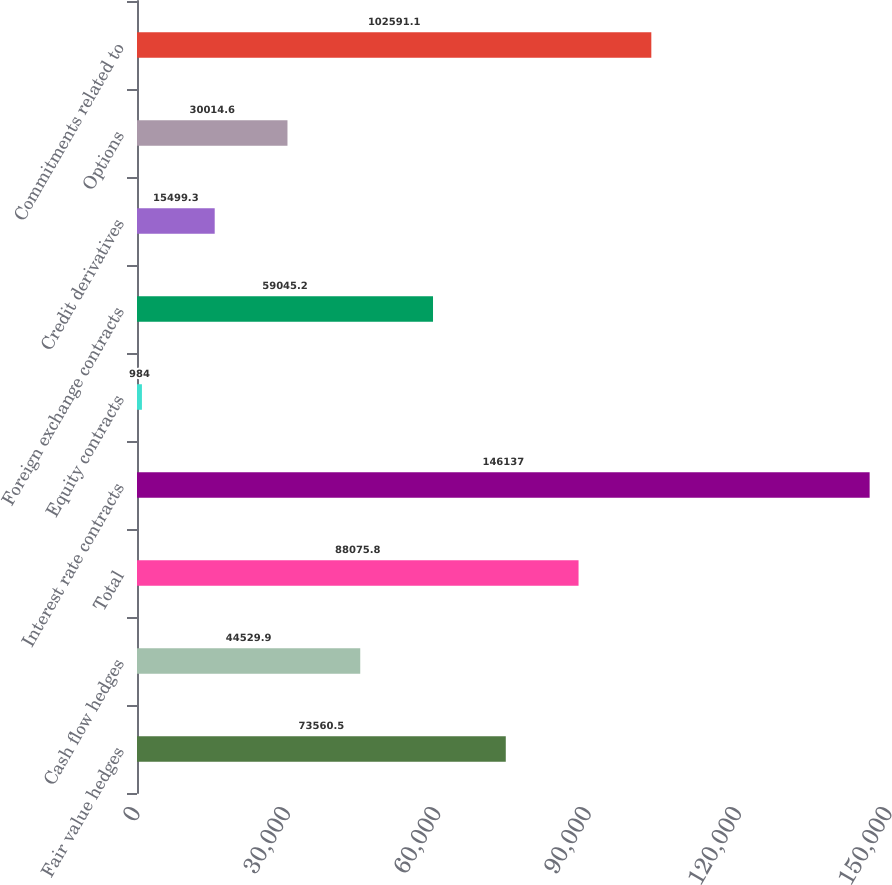<chart> <loc_0><loc_0><loc_500><loc_500><bar_chart><fcel>Fair value hedges<fcel>Cash flow hedges<fcel>Total<fcel>Interest rate contracts<fcel>Equity contracts<fcel>Foreign exchange contracts<fcel>Credit derivatives<fcel>Options<fcel>Commitments related to<nl><fcel>73560.5<fcel>44529.9<fcel>88075.8<fcel>146137<fcel>984<fcel>59045.2<fcel>15499.3<fcel>30014.6<fcel>102591<nl></chart> 